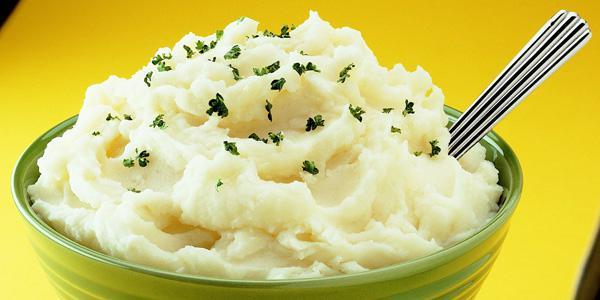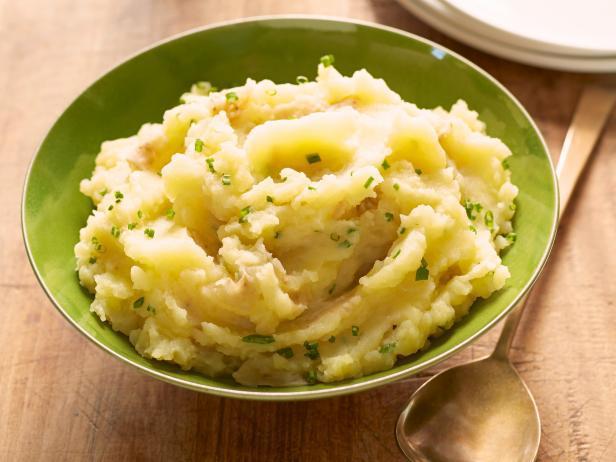The first image is the image on the left, the second image is the image on the right. For the images shown, is this caption "There is a utensil in the food in the image on the left." true? Answer yes or no. Yes. The first image is the image on the left, the second image is the image on the right. Examine the images to the left and right. Is the description "An image shows a spoon next to a dish." accurate? Answer yes or no. Yes. 